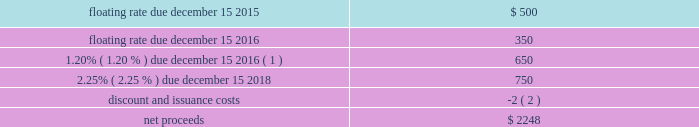Devon energy corporation and subsidiaries notes to consolidated financial statements 2013 ( continued ) other debentures and notes following are descriptions of the various other debentures and notes outstanding at december 31 , 2014 and 2013 , as listed in the table presented at the beginning of this note .
Geosouthern debt in december 2013 , in conjunction with the planned geosouthern acquisition , devon issued $ 2.25 billion aggregate principal amount of fixed and floating rate senior notes resulting in cash proceeds of approximately $ 2.2 billion , net of discounts and issuance costs .
The floating rate senior notes due in 2015 bear interest at a rate equal to three-month libor plus 0.45 percent , which rate will be reset quarterly .
The floating rate senior notes due in 2016 bears interest at a rate equal to three-month libor plus 0.54 percent , which rate will be reset quarterly .
The schedule below summarizes the key terms of these notes ( in millions ) . .
( 1 ) the 1.20% ( 1.20 % ) $ 650 million note due december 15 , 2016 was redeemed on november 13 , 2014 .
The senior notes were classified as short-term debt on devon 2019s consolidated balance sheet as of december 31 , 2013 due to certain redemption features in the event that the geosouthern acquisition was not completed on or prior to june 30 , 2014 .
On february 28 , 2014 , the geosouthern acquisition closed and thus the senior notes were subsequently classified as long-term debt .
Additionally , during december 2013 , devon entered into a term loan agreement with a group of major financial institutions pursuant to which devon could draw up to $ 2.0 billion to finance , in part , the geosouthern acquisition and to pay transaction costs .
In february 2014 , devon drew the $ 2.0 billion of term loans for the geosouthern transaction , and the amount was subsequently repaid on june 30 , 2014 with the canadian divestiture proceeds that were repatriated to the u.s .
In june 2014 , at which point the term loan was terminated. .
What is the ratio of the floating rate due december 2015 compared to 2016? 
Rationale: there was $ 1.43 due in 2015 for each $ 1 due in 2016
Computations: (500 / 350)
Answer: 1.42857. 